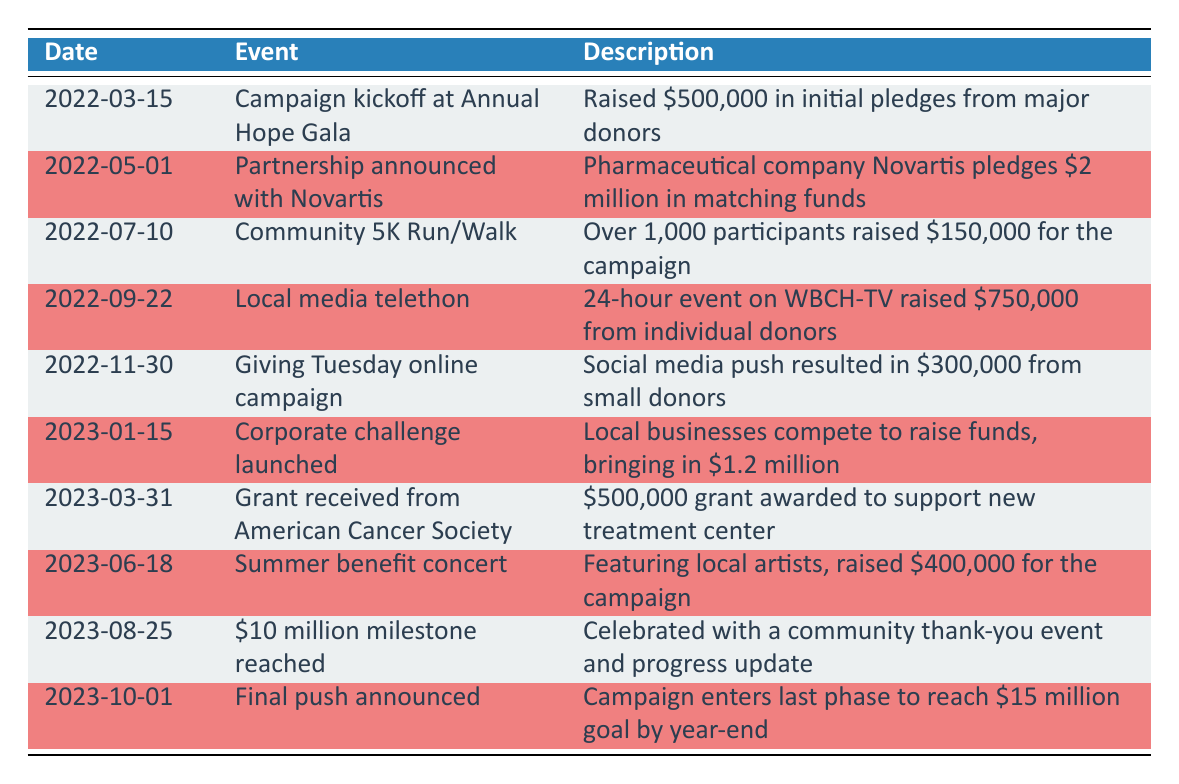What event occurred on March 15, 2022? The table indicates that a campaign kickoff event at the Annual Hope Gala took place on March 15, 2022, which raised $500,000 in initial pledges from major donors.
Answer: Campaign kickoff at Annual Hope Gala How much money did the community 5K Run/Walk raise? According to the table, the community 5K Run/Walk raised $150,000 for the campaign, with over 1,000 participants.
Answer: $150,000 Did the organization reach a $10 million milestone? Yes, the table shows that the organization celebrated reaching a $10 million milestone on August 25, 2023, with a community thank-you event.
Answer: Yes What was the total amount raised by the Corporate challenge launched on January 15, 2023? The table specifies that the Corporate challenge brought in $1.2 million, as local businesses competed to raise funds.
Answer: $1.2 million How much more money needs to be raised to meet the $15 million goal by year-end? From the table, as of October 1, 2023, the campaign has reached $10 million. Therefore, the remaining amount needed is $15 million - $10 million = $5 million.
Answer: $5 million What was the highest amount raised in a single event according to the table? The local media telethon on September 22, 2022, raised $750,000, which is the highest amount recorded for a single event in the table.
Answer: $750,000 Was there a partnership with Novartis, and if so, how much did they pledge? Yes, the table states that a partnership with Novartis was announced on May 1, 2022, where they pledged $2 million in matching funds.
Answer: Yes, $2 million What event contributed the least to the fundraising campaign, and how much did it raise? The Giving Tuesday online campaign on November 30, 2022, contributed the least to the campaign, raising $300,000, which is less than all other events listed in the table.
Answer: Giving Tuesday online campaign, $300,000 Which event took place just before the $10 million milestone was reached? The Summer benefit concert on June 18, 2023, took place just before the $10 million milestone was reached on August 25, 2023.
Answer: Summer benefit concert What was the total amount raised from individual donations during the telethon? The table shows that the telethon raised $750,000 from individual donors, making it a significant contribution to the campaign overall.
Answer: $750,000 